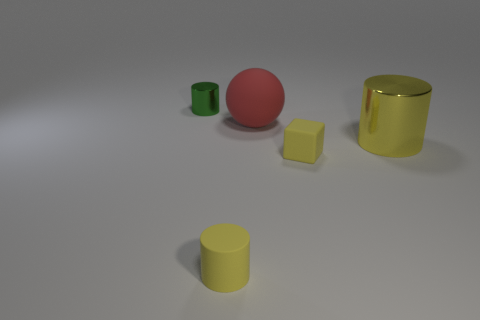Add 1 gray metal objects. How many objects exist? 6 Subtract all spheres. How many objects are left? 4 Add 3 green cylinders. How many green cylinders are left? 4 Add 3 big shiny cylinders. How many big shiny cylinders exist? 4 Subtract 0 cyan cylinders. How many objects are left? 5 Subtract all rubber cylinders. Subtract all spheres. How many objects are left? 3 